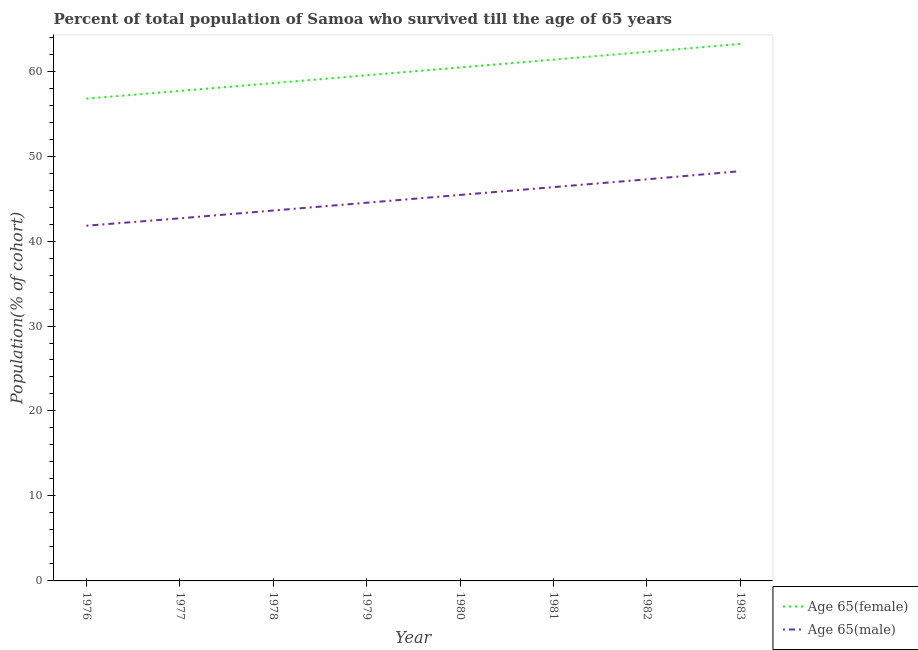Does the line corresponding to percentage of female population who survived till age of 65 intersect with the line corresponding to percentage of male population who survived till age of 65?
Give a very brief answer. No. Is the number of lines equal to the number of legend labels?
Your response must be concise. Yes. What is the percentage of male population who survived till age of 65 in 1977?
Offer a terse response. 42.67. Across all years, what is the maximum percentage of female population who survived till age of 65?
Provide a succinct answer. 63.19. Across all years, what is the minimum percentage of male population who survived till age of 65?
Give a very brief answer. 41.8. In which year was the percentage of female population who survived till age of 65 maximum?
Provide a succinct answer. 1983. In which year was the percentage of male population who survived till age of 65 minimum?
Your answer should be very brief. 1976. What is the total percentage of male population who survived till age of 65 in the graph?
Your answer should be compact. 359.83. What is the difference between the percentage of female population who survived till age of 65 in 1977 and that in 1983?
Make the answer very short. -5.53. What is the difference between the percentage of female population who survived till age of 65 in 1980 and the percentage of male population who survived till age of 65 in 1977?
Keep it short and to the point. 17.75. What is the average percentage of male population who survived till age of 65 per year?
Your answer should be very brief. 44.98. In the year 1982, what is the difference between the percentage of male population who survived till age of 65 and percentage of female population who survived till age of 65?
Provide a short and direct response. -15.01. What is the ratio of the percentage of female population who survived till age of 65 in 1980 to that in 1982?
Offer a terse response. 0.97. Is the percentage of female population who survived till age of 65 in 1976 less than that in 1982?
Offer a very short reply. Yes. What is the difference between the highest and the second highest percentage of female population who survived till age of 65?
Offer a terse response. 0.93. What is the difference between the highest and the lowest percentage of female population who survived till age of 65?
Keep it short and to the point. 6.44. Is the sum of the percentage of female population who survived till age of 65 in 1976 and 1983 greater than the maximum percentage of male population who survived till age of 65 across all years?
Offer a terse response. Yes. Is the percentage of female population who survived till age of 65 strictly greater than the percentage of male population who survived till age of 65 over the years?
Ensure brevity in your answer.  Yes. How many years are there in the graph?
Your answer should be compact. 8. Where does the legend appear in the graph?
Keep it short and to the point. Bottom right. How are the legend labels stacked?
Make the answer very short. Vertical. What is the title of the graph?
Offer a terse response. Percent of total population of Samoa who survived till the age of 65 years. Does "Measles" appear as one of the legend labels in the graph?
Your response must be concise. No. What is the label or title of the Y-axis?
Keep it short and to the point. Population(% of cohort). What is the Population(% of cohort) in Age 65(female) in 1976?
Make the answer very short. 56.76. What is the Population(% of cohort) of Age 65(male) in 1976?
Your answer should be compact. 41.8. What is the Population(% of cohort) of Age 65(female) in 1977?
Give a very brief answer. 57.66. What is the Population(% of cohort) in Age 65(male) in 1977?
Keep it short and to the point. 42.67. What is the Population(% of cohort) of Age 65(female) in 1978?
Your answer should be compact. 58.59. What is the Population(% of cohort) in Age 65(male) in 1978?
Your answer should be compact. 43.59. What is the Population(% of cohort) in Age 65(female) in 1979?
Give a very brief answer. 59.51. What is the Population(% of cohort) of Age 65(male) in 1979?
Give a very brief answer. 44.51. What is the Population(% of cohort) of Age 65(female) in 1980?
Offer a terse response. 60.43. What is the Population(% of cohort) of Age 65(male) in 1980?
Ensure brevity in your answer.  45.43. What is the Population(% of cohort) of Age 65(female) in 1981?
Provide a succinct answer. 61.35. What is the Population(% of cohort) in Age 65(male) in 1981?
Offer a terse response. 46.34. What is the Population(% of cohort) in Age 65(female) in 1982?
Ensure brevity in your answer.  62.27. What is the Population(% of cohort) in Age 65(male) in 1982?
Offer a very short reply. 47.26. What is the Population(% of cohort) in Age 65(female) in 1983?
Your response must be concise. 63.19. What is the Population(% of cohort) of Age 65(male) in 1983?
Ensure brevity in your answer.  48.22. Across all years, what is the maximum Population(% of cohort) of Age 65(female)?
Your answer should be very brief. 63.19. Across all years, what is the maximum Population(% of cohort) of Age 65(male)?
Provide a short and direct response. 48.22. Across all years, what is the minimum Population(% of cohort) of Age 65(female)?
Your answer should be very brief. 56.76. Across all years, what is the minimum Population(% of cohort) of Age 65(male)?
Ensure brevity in your answer.  41.8. What is the total Population(% of cohort) of Age 65(female) in the graph?
Keep it short and to the point. 479.75. What is the total Population(% of cohort) in Age 65(male) in the graph?
Provide a short and direct response. 359.83. What is the difference between the Population(% of cohort) in Age 65(female) in 1976 and that in 1977?
Your answer should be very brief. -0.91. What is the difference between the Population(% of cohort) of Age 65(male) in 1976 and that in 1977?
Provide a succinct answer. -0.87. What is the difference between the Population(% of cohort) in Age 65(female) in 1976 and that in 1978?
Your answer should be compact. -1.83. What is the difference between the Population(% of cohort) of Age 65(male) in 1976 and that in 1978?
Make the answer very short. -1.79. What is the difference between the Population(% of cohort) of Age 65(female) in 1976 and that in 1979?
Offer a very short reply. -2.75. What is the difference between the Population(% of cohort) in Age 65(male) in 1976 and that in 1979?
Provide a succinct answer. -2.71. What is the difference between the Population(% of cohort) of Age 65(female) in 1976 and that in 1980?
Keep it short and to the point. -3.67. What is the difference between the Population(% of cohort) in Age 65(male) in 1976 and that in 1980?
Provide a succinct answer. -3.62. What is the difference between the Population(% of cohort) in Age 65(female) in 1976 and that in 1981?
Offer a very short reply. -4.59. What is the difference between the Population(% of cohort) in Age 65(male) in 1976 and that in 1981?
Ensure brevity in your answer.  -4.54. What is the difference between the Population(% of cohort) in Age 65(female) in 1976 and that in 1982?
Your response must be concise. -5.51. What is the difference between the Population(% of cohort) of Age 65(male) in 1976 and that in 1982?
Ensure brevity in your answer.  -5.46. What is the difference between the Population(% of cohort) of Age 65(female) in 1976 and that in 1983?
Your answer should be compact. -6.44. What is the difference between the Population(% of cohort) in Age 65(male) in 1976 and that in 1983?
Keep it short and to the point. -6.42. What is the difference between the Population(% of cohort) in Age 65(female) in 1977 and that in 1978?
Give a very brief answer. -0.92. What is the difference between the Population(% of cohort) of Age 65(male) in 1977 and that in 1978?
Give a very brief answer. -0.92. What is the difference between the Population(% of cohort) in Age 65(female) in 1977 and that in 1979?
Give a very brief answer. -1.84. What is the difference between the Population(% of cohort) of Age 65(male) in 1977 and that in 1979?
Give a very brief answer. -1.84. What is the difference between the Population(% of cohort) in Age 65(female) in 1977 and that in 1980?
Your answer should be very brief. -2.76. What is the difference between the Population(% of cohort) in Age 65(male) in 1977 and that in 1980?
Your answer should be compact. -2.75. What is the difference between the Population(% of cohort) in Age 65(female) in 1977 and that in 1981?
Ensure brevity in your answer.  -3.68. What is the difference between the Population(% of cohort) in Age 65(male) in 1977 and that in 1981?
Offer a very short reply. -3.67. What is the difference between the Population(% of cohort) in Age 65(female) in 1977 and that in 1982?
Your answer should be very brief. -4.6. What is the difference between the Population(% of cohort) of Age 65(male) in 1977 and that in 1982?
Keep it short and to the point. -4.59. What is the difference between the Population(% of cohort) of Age 65(female) in 1977 and that in 1983?
Your answer should be compact. -5.53. What is the difference between the Population(% of cohort) in Age 65(male) in 1977 and that in 1983?
Offer a very short reply. -5.55. What is the difference between the Population(% of cohort) in Age 65(female) in 1978 and that in 1979?
Your answer should be compact. -0.92. What is the difference between the Population(% of cohort) in Age 65(male) in 1978 and that in 1979?
Your answer should be compact. -0.92. What is the difference between the Population(% of cohort) of Age 65(female) in 1978 and that in 1980?
Offer a terse response. -1.84. What is the difference between the Population(% of cohort) of Age 65(male) in 1978 and that in 1980?
Offer a terse response. -1.84. What is the difference between the Population(% of cohort) in Age 65(female) in 1978 and that in 1981?
Your answer should be compact. -2.76. What is the difference between the Population(% of cohort) of Age 65(male) in 1978 and that in 1981?
Make the answer very short. -2.75. What is the difference between the Population(% of cohort) of Age 65(female) in 1978 and that in 1982?
Ensure brevity in your answer.  -3.68. What is the difference between the Population(% of cohort) in Age 65(male) in 1978 and that in 1982?
Your response must be concise. -3.67. What is the difference between the Population(% of cohort) of Age 65(female) in 1978 and that in 1983?
Your answer should be very brief. -4.61. What is the difference between the Population(% of cohort) in Age 65(male) in 1978 and that in 1983?
Make the answer very short. -4.63. What is the difference between the Population(% of cohort) in Age 65(female) in 1979 and that in 1980?
Keep it short and to the point. -0.92. What is the difference between the Population(% of cohort) in Age 65(male) in 1979 and that in 1980?
Offer a very short reply. -0.92. What is the difference between the Population(% of cohort) in Age 65(female) in 1979 and that in 1981?
Offer a terse response. -1.84. What is the difference between the Population(% of cohort) of Age 65(male) in 1979 and that in 1981?
Offer a very short reply. -1.84. What is the difference between the Population(% of cohort) in Age 65(female) in 1979 and that in 1982?
Your answer should be compact. -2.76. What is the difference between the Population(% of cohort) of Age 65(male) in 1979 and that in 1982?
Offer a terse response. -2.75. What is the difference between the Population(% of cohort) in Age 65(female) in 1979 and that in 1983?
Offer a terse response. -3.69. What is the difference between the Population(% of cohort) in Age 65(male) in 1979 and that in 1983?
Your answer should be very brief. -3.72. What is the difference between the Population(% of cohort) of Age 65(female) in 1980 and that in 1981?
Offer a very short reply. -0.92. What is the difference between the Population(% of cohort) of Age 65(male) in 1980 and that in 1981?
Your response must be concise. -0.92. What is the difference between the Population(% of cohort) in Age 65(female) in 1980 and that in 1982?
Your answer should be compact. -1.84. What is the difference between the Population(% of cohort) in Age 65(male) in 1980 and that in 1982?
Your answer should be compact. -1.84. What is the difference between the Population(% of cohort) in Age 65(female) in 1980 and that in 1983?
Give a very brief answer. -2.77. What is the difference between the Population(% of cohort) of Age 65(male) in 1980 and that in 1983?
Ensure brevity in your answer.  -2.8. What is the difference between the Population(% of cohort) in Age 65(female) in 1981 and that in 1982?
Provide a short and direct response. -0.92. What is the difference between the Population(% of cohort) in Age 65(male) in 1981 and that in 1982?
Make the answer very short. -0.92. What is the difference between the Population(% of cohort) in Age 65(female) in 1981 and that in 1983?
Provide a short and direct response. -1.85. What is the difference between the Population(% of cohort) in Age 65(male) in 1981 and that in 1983?
Your answer should be very brief. -1.88. What is the difference between the Population(% of cohort) in Age 65(female) in 1982 and that in 1983?
Make the answer very short. -0.93. What is the difference between the Population(% of cohort) in Age 65(male) in 1982 and that in 1983?
Make the answer very short. -0.96. What is the difference between the Population(% of cohort) in Age 65(female) in 1976 and the Population(% of cohort) in Age 65(male) in 1977?
Your response must be concise. 14.09. What is the difference between the Population(% of cohort) of Age 65(female) in 1976 and the Population(% of cohort) of Age 65(male) in 1978?
Your answer should be compact. 13.17. What is the difference between the Population(% of cohort) of Age 65(female) in 1976 and the Population(% of cohort) of Age 65(male) in 1979?
Offer a very short reply. 12.25. What is the difference between the Population(% of cohort) in Age 65(female) in 1976 and the Population(% of cohort) in Age 65(male) in 1980?
Your answer should be very brief. 11.33. What is the difference between the Population(% of cohort) in Age 65(female) in 1976 and the Population(% of cohort) in Age 65(male) in 1981?
Make the answer very short. 10.41. What is the difference between the Population(% of cohort) of Age 65(female) in 1976 and the Population(% of cohort) of Age 65(male) in 1982?
Make the answer very short. 9.5. What is the difference between the Population(% of cohort) of Age 65(female) in 1976 and the Population(% of cohort) of Age 65(male) in 1983?
Your answer should be compact. 8.53. What is the difference between the Population(% of cohort) of Age 65(female) in 1977 and the Population(% of cohort) of Age 65(male) in 1978?
Your response must be concise. 14.07. What is the difference between the Population(% of cohort) of Age 65(female) in 1977 and the Population(% of cohort) of Age 65(male) in 1979?
Make the answer very short. 13.16. What is the difference between the Population(% of cohort) of Age 65(female) in 1977 and the Population(% of cohort) of Age 65(male) in 1980?
Keep it short and to the point. 12.24. What is the difference between the Population(% of cohort) of Age 65(female) in 1977 and the Population(% of cohort) of Age 65(male) in 1981?
Offer a terse response. 11.32. What is the difference between the Population(% of cohort) of Age 65(female) in 1977 and the Population(% of cohort) of Age 65(male) in 1982?
Provide a short and direct response. 10.4. What is the difference between the Population(% of cohort) of Age 65(female) in 1977 and the Population(% of cohort) of Age 65(male) in 1983?
Your response must be concise. 9.44. What is the difference between the Population(% of cohort) of Age 65(female) in 1978 and the Population(% of cohort) of Age 65(male) in 1979?
Keep it short and to the point. 14.08. What is the difference between the Population(% of cohort) in Age 65(female) in 1978 and the Population(% of cohort) in Age 65(male) in 1980?
Make the answer very short. 13.16. What is the difference between the Population(% of cohort) of Age 65(female) in 1978 and the Population(% of cohort) of Age 65(male) in 1981?
Offer a terse response. 12.24. What is the difference between the Population(% of cohort) in Age 65(female) in 1978 and the Population(% of cohort) in Age 65(male) in 1982?
Make the answer very short. 11.32. What is the difference between the Population(% of cohort) of Age 65(female) in 1978 and the Population(% of cohort) of Age 65(male) in 1983?
Keep it short and to the point. 10.36. What is the difference between the Population(% of cohort) of Age 65(female) in 1979 and the Population(% of cohort) of Age 65(male) in 1980?
Your response must be concise. 14.08. What is the difference between the Population(% of cohort) of Age 65(female) in 1979 and the Population(% of cohort) of Age 65(male) in 1981?
Make the answer very short. 13.16. What is the difference between the Population(% of cohort) in Age 65(female) in 1979 and the Population(% of cohort) in Age 65(male) in 1982?
Make the answer very short. 12.24. What is the difference between the Population(% of cohort) in Age 65(female) in 1979 and the Population(% of cohort) in Age 65(male) in 1983?
Your answer should be compact. 11.28. What is the difference between the Population(% of cohort) in Age 65(female) in 1980 and the Population(% of cohort) in Age 65(male) in 1981?
Your answer should be compact. 14.08. What is the difference between the Population(% of cohort) of Age 65(female) in 1980 and the Population(% of cohort) of Age 65(male) in 1982?
Offer a very short reply. 13.16. What is the difference between the Population(% of cohort) of Age 65(female) in 1980 and the Population(% of cohort) of Age 65(male) in 1983?
Offer a terse response. 12.2. What is the difference between the Population(% of cohort) of Age 65(female) in 1981 and the Population(% of cohort) of Age 65(male) in 1982?
Give a very brief answer. 14.09. What is the difference between the Population(% of cohort) in Age 65(female) in 1981 and the Population(% of cohort) in Age 65(male) in 1983?
Your response must be concise. 13.12. What is the difference between the Population(% of cohort) in Age 65(female) in 1982 and the Population(% of cohort) in Age 65(male) in 1983?
Ensure brevity in your answer.  14.04. What is the average Population(% of cohort) in Age 65(female) per year?
Your answer should be compact. 59.97. What is the average Population(% of cohort) of Age 65(male) per year?
Provide a succinct answer. 44.98. In the year 1976, what is the difference between the Population(% of cohort) of Age 65(female) and Population(% of cohort) of Age 65(male)?
Keep it short and to the point. 14.96. In the year 1977, what is the difference between the Population(% of cohort) of Age 65(female) and Population(% of cohort) of Age 65(male)?
Give a very brief answer. 14.99. In the year 1978, what is the difference between the Population(% of cohort) in Age 65(female) and Population(% of cohort) in Age 65(male)?
Provide a succinct answer. 14.99. In the year 1979, what is the difference between the Population(% of cohort) of Age 65(female) and Population(% of cohort) of Age 65(male)?
Keep it short and to the point. 15. In the year 1980, what is the difference between the Population(% of cohort) in Age 65(female) and Population(% of cohort) in Age 65(male)?
Your answer should be very brief. 15. In the year 1981, what is the difference between the Population(% of cohort) in Age 65(female) and Population(% of cohort) in Age 65(male)?
Ensure brevity in your answer.  15. In the year 1982, what is the difference between the Population(% of cohort) of Age 65(female) and Population(% of cohort) of Age 65(male)?
Make the answer very short. 15.01. In the year 1983, what is the difference between the Population(% of cohort) in Age 65(female) and Population(% of cohort) in Age 65(male)?
Make the answer very short. 14.97. What is the ratio of the Population(% of cohort) of Age 65(female) in 1976 to that in 1977?
Provide a succinct answer. 0.98. What is the ratio of the Population(% of cohort) in Age 65(male) in 1976 to that in 1977?
Provide a succinct answer. 0.98. What is the ratio of the Population(% of cohort) of Age 65(female) in 1976 to that in 1978?
Offer a very short reply. 0.97. What is the ratio of the Population(% of cohort) in Age 65(male) in 1976 to that in 1978?
Provide a succinct answer. 0.96. What is the ratio of the Population(% of cohort) in Age 65(female) in 1976 to that in 1979?
Keep it short and to the point. 0.95. What is the ratio of the Population(% of cohort) of Age 65(male) in 1976 to that in 1979?
Offer a terse response. 0.94. What is the ratio of the Population(% of cohort) in Age 65(female) in 1976 to that in 1980?
Ensure brevity in your answer.  0.94. What is the ratio of the Population(% of cohort) in Age 65(male) in 1976 to that in 1980?
Offer a terse response. 0.92. What is the ratio of the Population(% of cohort) in Age 65(female) in 1976 to that in 1981?
Your answer should be compact. 0.93. What is the ratio of the Population(% of cohort) of Age 65(male) in 1976 to that in 1981?
Your response must be concise. 0.9. What is the ratio of the Population(% of cohort) in Age 65(female) in 1976 to that in 1982?
Make the answer very short. 0.91. What is the ratio of the Population(% of cohort) in Age 65(male) in 1976 to that in 1982?
Keep it short and to the point. 0.88. What is the ratio of the Population(% of cohort) of Age 65(female) in 1976 to that in 1983?
Give a very brief answer. 0.9. What is the ratio of the Population(% of cohort) in Age 65(male) in 1976 to that in 1983?
Offer a terse response. 0.87. What is the ratio of the Population(% of cohort) in Age 65(female) in 1977 to that in 1978?
Make the answer very short. 0.98. What is the ratio of the Population(% of cohort) of Age 65(male) in 1977 to that in 1978?
Keep it short and to the point. 0.98. What is the ratio of the Population(% of cohort) in Age 65(female) in 1977 to that in 1979?
Make the answer very short. 0.97. What is the ratio of the Population(% of cohort) in Age 65(male) in 1977 to that in 1979?
Your response must be concise. 0.96. What is the ratio of the Population(% of cohort) in Age 65(female) in 1977 to that in 1980?
Offer a terse response. 0.95. What is the ratio of the Population(% of cohort) in Age 65(male) in 1977 to that in 1980?
Make the answer very short. 0.94. What is the ratio of the Population(% of cohort) of Age 65(male) in 1977 to that in 1981?
Your answer should be very brief. 0.92. What is the ratio of the Population(% of cohort) of Age 65(female) in 1977 to that in 1982?
Provide a short and direct response. 0.93. What is the ratio of the Population(% of cohort) of Age 65(male) in 1977 to that in 1982?
Provide a succinct answer. 0.9. What is the ratio of the Population(% of cohort) of Age 65(female) in 1977 to that in 1983?
Your response must be concise. 0.91. What is the ratio of the Population(% of cohort) in Age 65(male) in 1977 to that in 1983?
Your answer should be very brief. 0.88. What is the ratio of the Population(% of cohort) in Age 65(female) in 1978 to that in 1979?
Ensure brevity in your answer.  0.98. What is the ratio of the Population(% of cohort) in Age 65(male) in 1978 to that in 1979?
Your answer should be very brief. 0.98. What is the ratio of the Population(% of cohort) of Age 65(female) in 1978 to that in 1980?
Give a very brief answer. 0.97. What is the ratio of the Population(% of cohort) of Age 65(male) in 1978 to that in 1980?
Ensure brevity in your answer.  0.96. What is the ratio of the Population(% of cohort) of Age 65(female) in 1978 to that in 1981?
Give a very brief answer. 0.95. What is the ratio of the Population(% of cohort) of Age 65(male) in 1978 to that in 1981?
Make the answer very short. 0.94. What is the ratio of the Population(% of cohort) of Age 65(female) in 1978 to that in 1982?
Your answer should be very brief. 0.94. What is the ratio of the Population(% of cohort) in Age 65(male) in 1978 to that in 1982?
Give a very brief answer. 0.92. What is the ratio of the Population(% of cohort) of Age 65(female) in 1978 to that in 1983?
Provide a short and direct response. 0.93. What is the ratio of the Population(% of cohort) of Age 65(male) in 1978 to that in 1983?
Provide a succinct answer. 0.9. What is the ratio of the Population(% of cohort) of Age 65(female) in 1979 to that in 1980?
Make the answer very short. 0.98. What is the ratio of the Population(% of cohort) of Age 65(male) in 1979 to that in 1980?
Give a very brief answer. 0.98. What is the ratio of the Population(% of cohort) of Age 65(male) in 1979 to that in 1981?
Your answer should be compact. 0.96. What is the ratio of the Population(% of cohort) of Age 65(female) in 1979 to that in 1982?
Make the answer very short. 0.96. What is the ratio of the Population(% of cohort) of Age 65(male) in 1979 to that in 1982?
Give a very brief answer. 0.94. What is the ratio of the Population(% of cohort) in Age 65(female) in 1979 to that in 1983?
Provide a succinct answer. 0.94. What is the ratio of the Population(% of cohort) of Age 65(male) in 1979 to that in 1983?
Provide a succinct answer. 0.92. What is the ratio of the Population(% of cohort) of Age 65(male) in 1980 to that in 1981?
Your answer should be compact. 0.98. What is the ratio of the Population(% of cohort) of Age 65(female) in 1980 to that in 1982?
Your answer should be very brief. 0.97. What is the ratio of the Population(% of cohort) of Age 65(male) in 1980 to that in 1982?
Make the answer very short. 0.96. What is the ratio of the Population(% of cohort) of Age 65(female) in 1980 to that in 1983?
Your response must be concise. 0.96. What is the ratio of the Population(% of cohort) in Age 65(male) in 1980 to that in 1983?
Your answer should be very brief. 0.94. What is the ratio of the Population(% of cohort) of Age 65(female) in 1981 to that in 1982?
Make the answer very short. 0.99. What is the ratio of the Population(% of cohort) in Age 65(male) in 1981 to that in 1982?
Offer a terse response. 0.98. What is the ratio of the Population(% of cohort) in Age 65(female) in 1981 to that in 1983?
Provide a short and direct response. 0.97. What is the ratio of the Population(% of cohort) in Age 65(male) in 1981 to that in 1983?
Offer a terse response. 0.96. What is the ratio of the Population(% of cohort) of Age 65(female) in 1982 to that in 1983?
Ensure brevity in your answer.  0.99. What is the ratio of the Population(% of cohort) in Age 65(male) in 1982 to that in 1983?
Make the answer very short. 0.98. What is the difference between the highest and the second highest Population(% of cohort) of Age 65(female)?
Provide a short and direct response. 0.93. What is the difference between the highest and the second highest Population(% of cohort) of Age 65(male)?
Provide a short and direct response. 0.96. What is the difference between the highest and the lowest Population(% of cohort) in Age 65(female)?
Provide a succinct answer. 6.44. What is the difference between the highest and the lowest Population(% of cohort) of Age 65(male)?
Offer a very short reply. 6.42. 